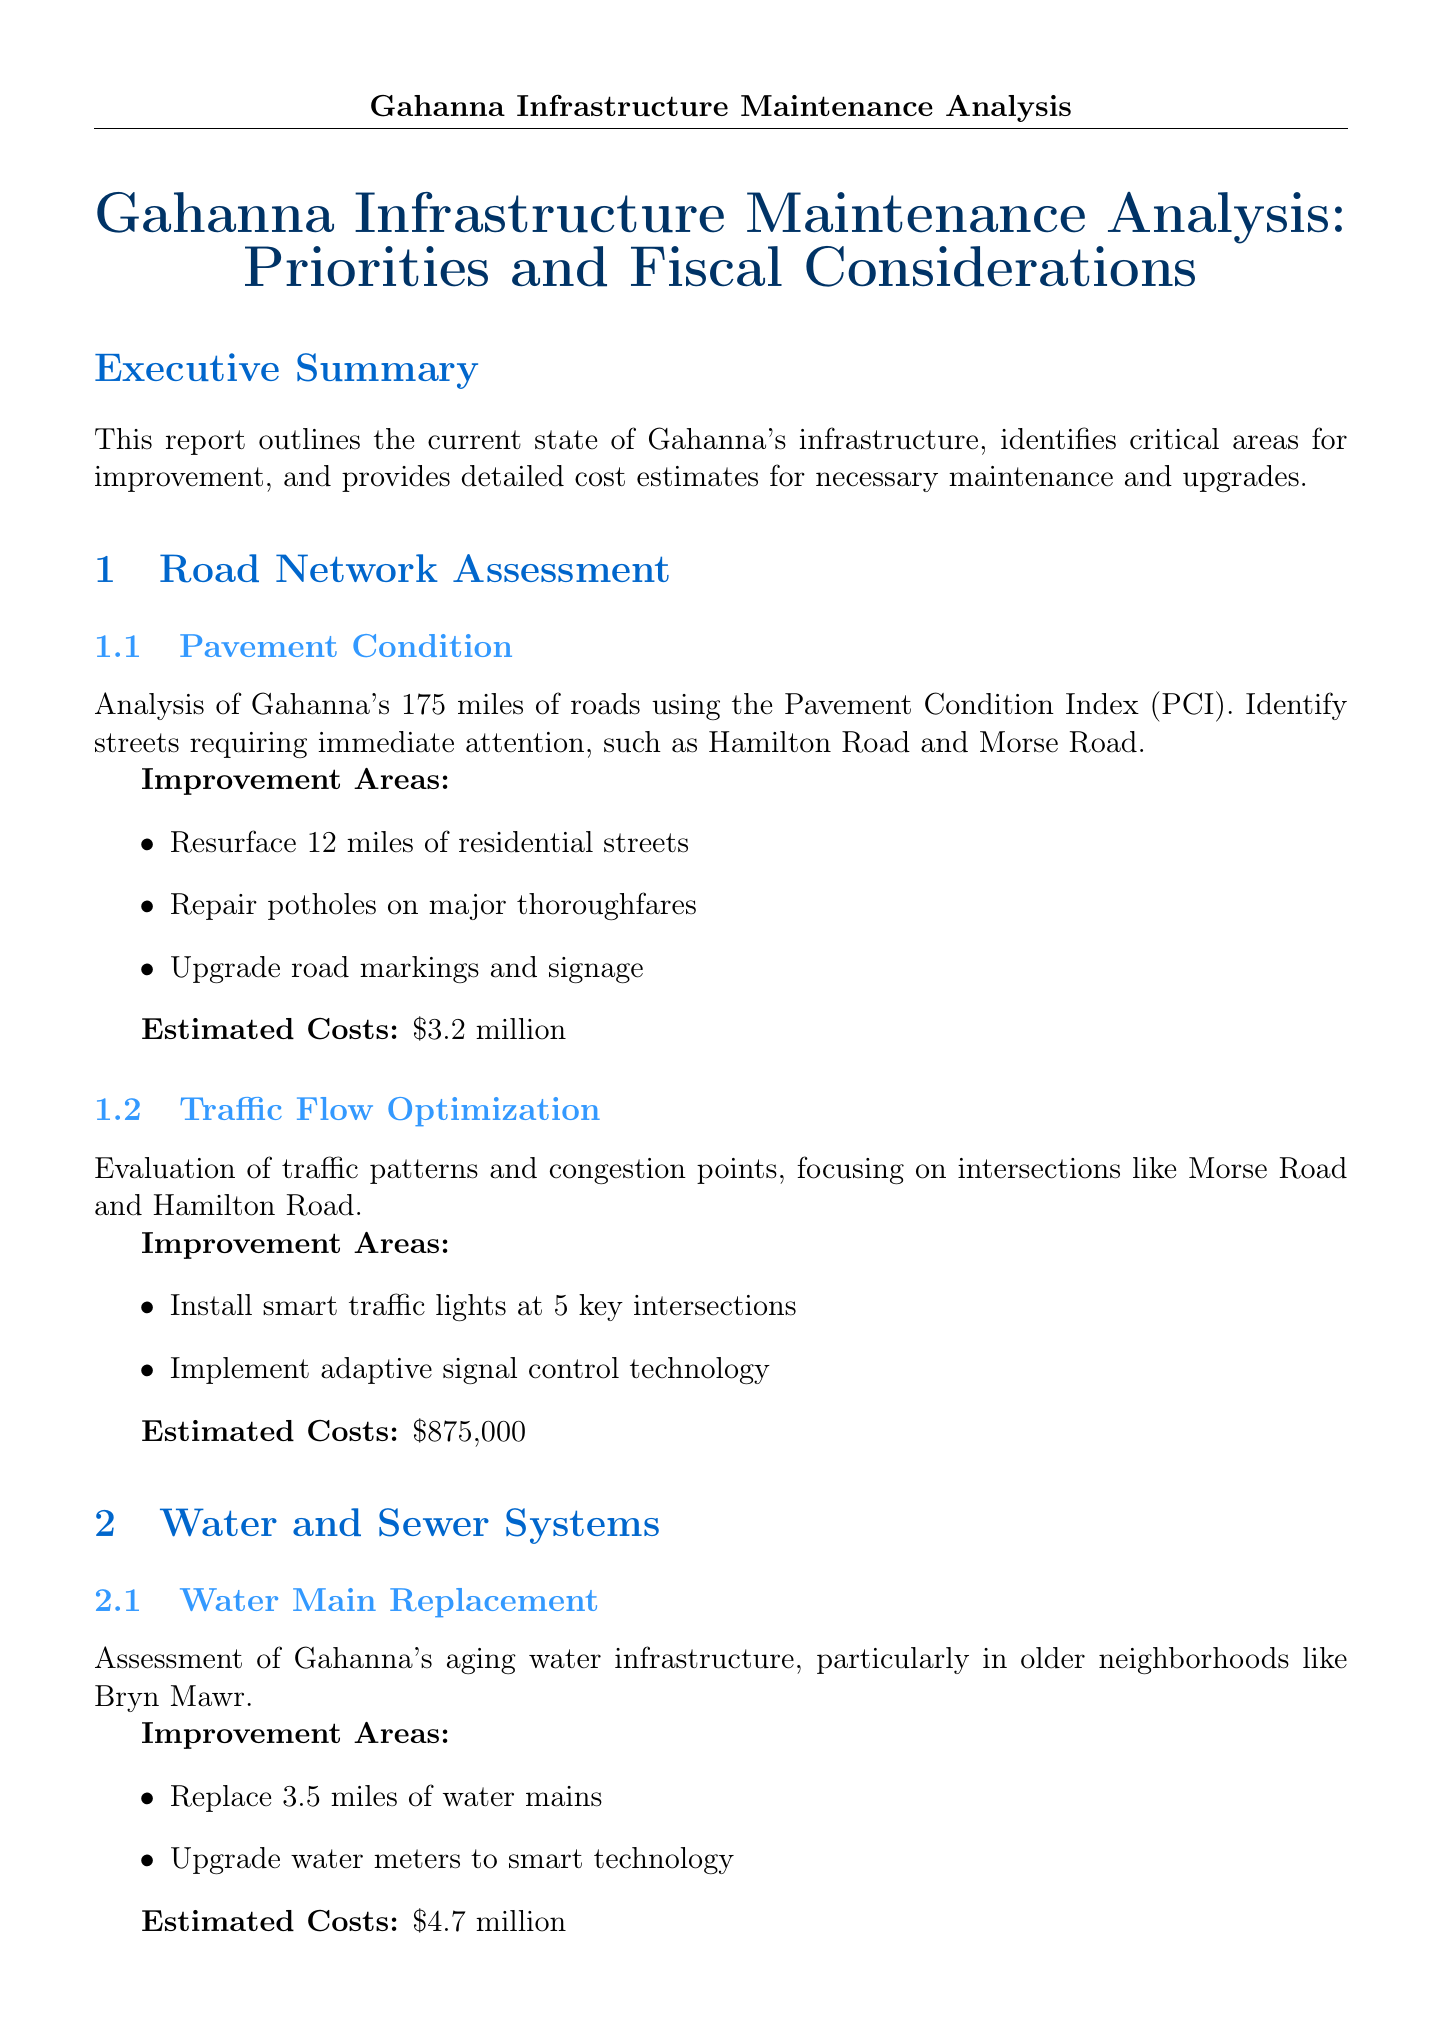what is the total estimated cost for all proposed upgrades and maintenance? The total estimated cost is mentioned in the conclusion of the report.
Answer: $19.375 million which streets require immediate attention according to the pavement condition assessment? The report identifies specific streets mentioned in the pavement condition assessment section.
Answer: Hamilton Road and Morse Road how many miles of residential streets need to be resurfaced? The pavement condition subsection lists the specific improvement area regarding resurfacing.
Answer: 12 miles what technology is proposed to improve traffic flow at key intersections? The report specifies two types of technology to improve traffic flow in the traffic flow optimization section.
Answer: Smart traffic lights which area of Gahanna is highlighted for water main replacement? The water main replacement subsection provides details about specific neighborhoods requiring attention.
Answer: Bryn Mawr what is the estimated cost for upgrading municipal buildings? This information is detailed in the municipal buildings subsection of the public facilities section.
Answer: $2.3 million how many key intersections will have smart traffic lights installed? The evaluation in the traffic flow optimization subsection outlines the number of intersections planned for this improvement.
Answer: 5 what kind of environmental solutions are proposed for sewer system upgrades? The report specifies two specific types of solutions for sewer system upgrades.
Answer: Green infrastructure solutions what is one of the recommendations for managing budget constraints? The recommendations section provides guidance on how to handle costs over time.
Answer: Implement a phased approach over 5 years 